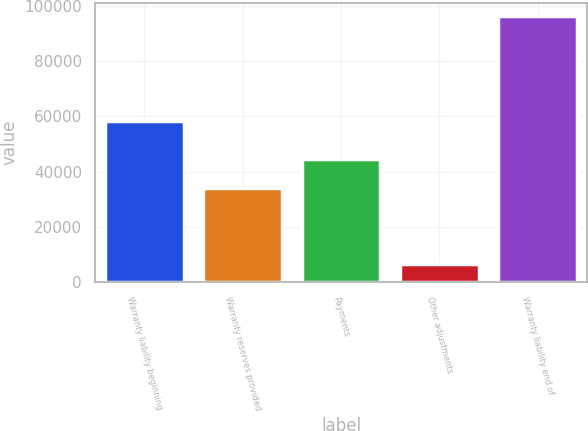Convert chart to OTSL. <chart><loc_0><loc_0><loc_500><loc_500><bar_chart><fcel>Warranty liability beginning<fcel>Warranty reserves provided<fcel>Payments<fcel>Other adjustments<fcel>Warranty liability end of<nl><fcel>58178<fcel>34019<fcel>44600<fcel>6779<fcel>96110<nl></chart> 